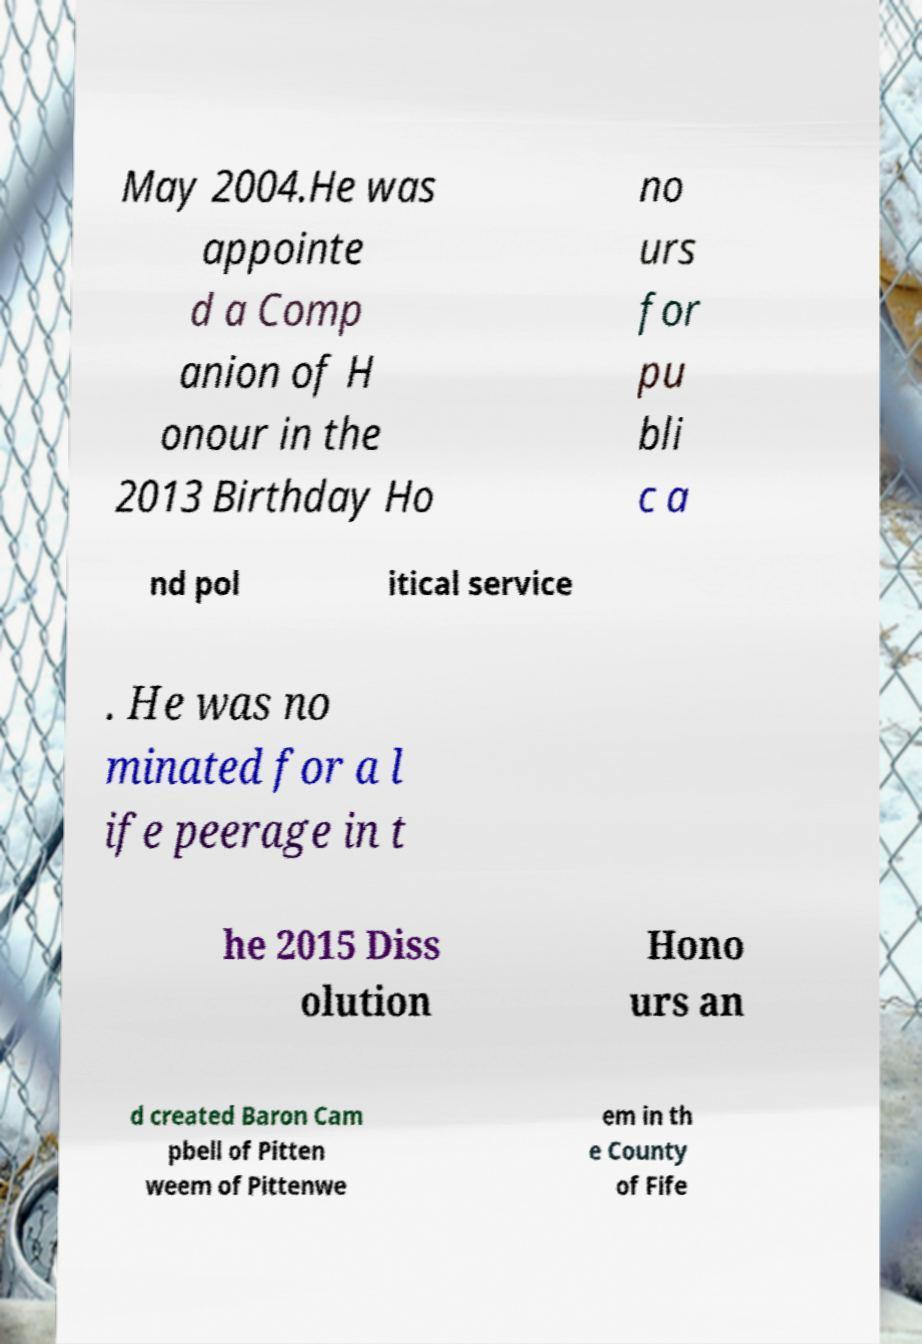Can you accurately transcribe the text from the provided image for me? May 2004.He was appointe d a Comp anion of H onour in the 2013 Birthday Ho no urs for pu bli c a nd pol itical service . He was no minated for a l ife peerage in t he 2015 Diss olution Hono urs an d created Baron Cam pbell of Pitten weem of Pittenwe em in th e County of Fife 